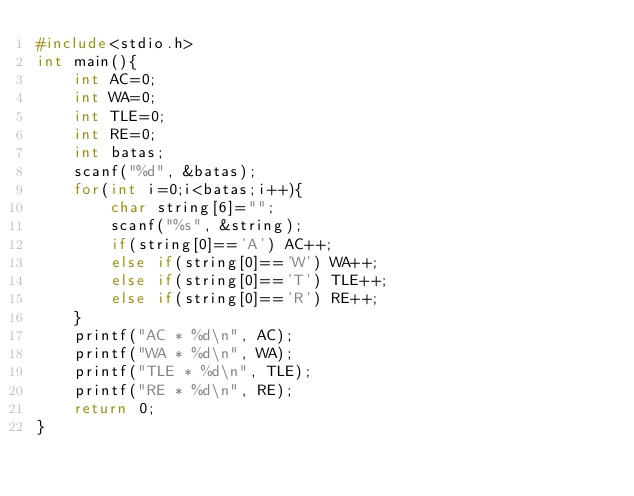<code> <loc_0><loc_0><loc_500><loc_500><_C++_>#include<stdio.h>
int main(){
	int AC=0;
	int WA=0;
	int TLE=0;
	int RE=0;
	int batas;
	scanf("%d", &batas);
	for(int i=0;i<batas;i++){
		char string[6]="";
		scanf("%s", &string);
		if(string[0]=='A') AC++;
		else if(string[0]=='W') WA++;
		else if(string[0]=='T') TLE++;
		else if(string[0]=='R') RE++;	
	}
	printf("AC * %d\n", AC);
	printf("WA * %d\n", WA);
	printf("TLE * %d\n", TLE);
	printf("RE * %d\n", RE);
	return 0;
}</code> 